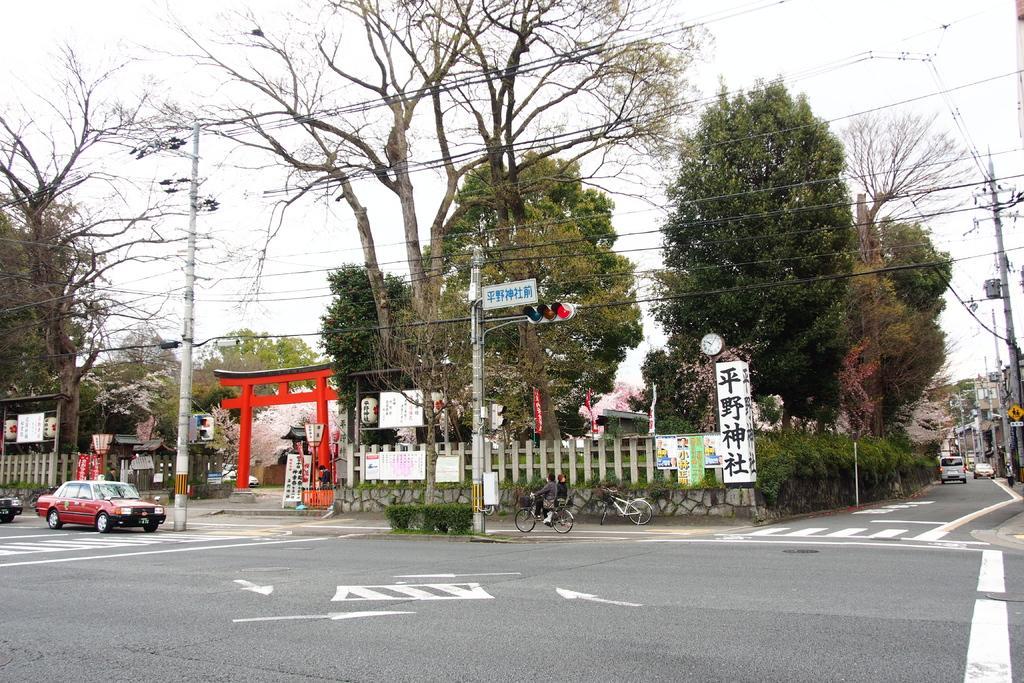Please provide a concise description of this image. In the image we can see in there are cars and other vehicles parked on the road and the person is sitting on the bicycle. There are traffic light signals, behind there are lot of trees and there are electric light poles. 